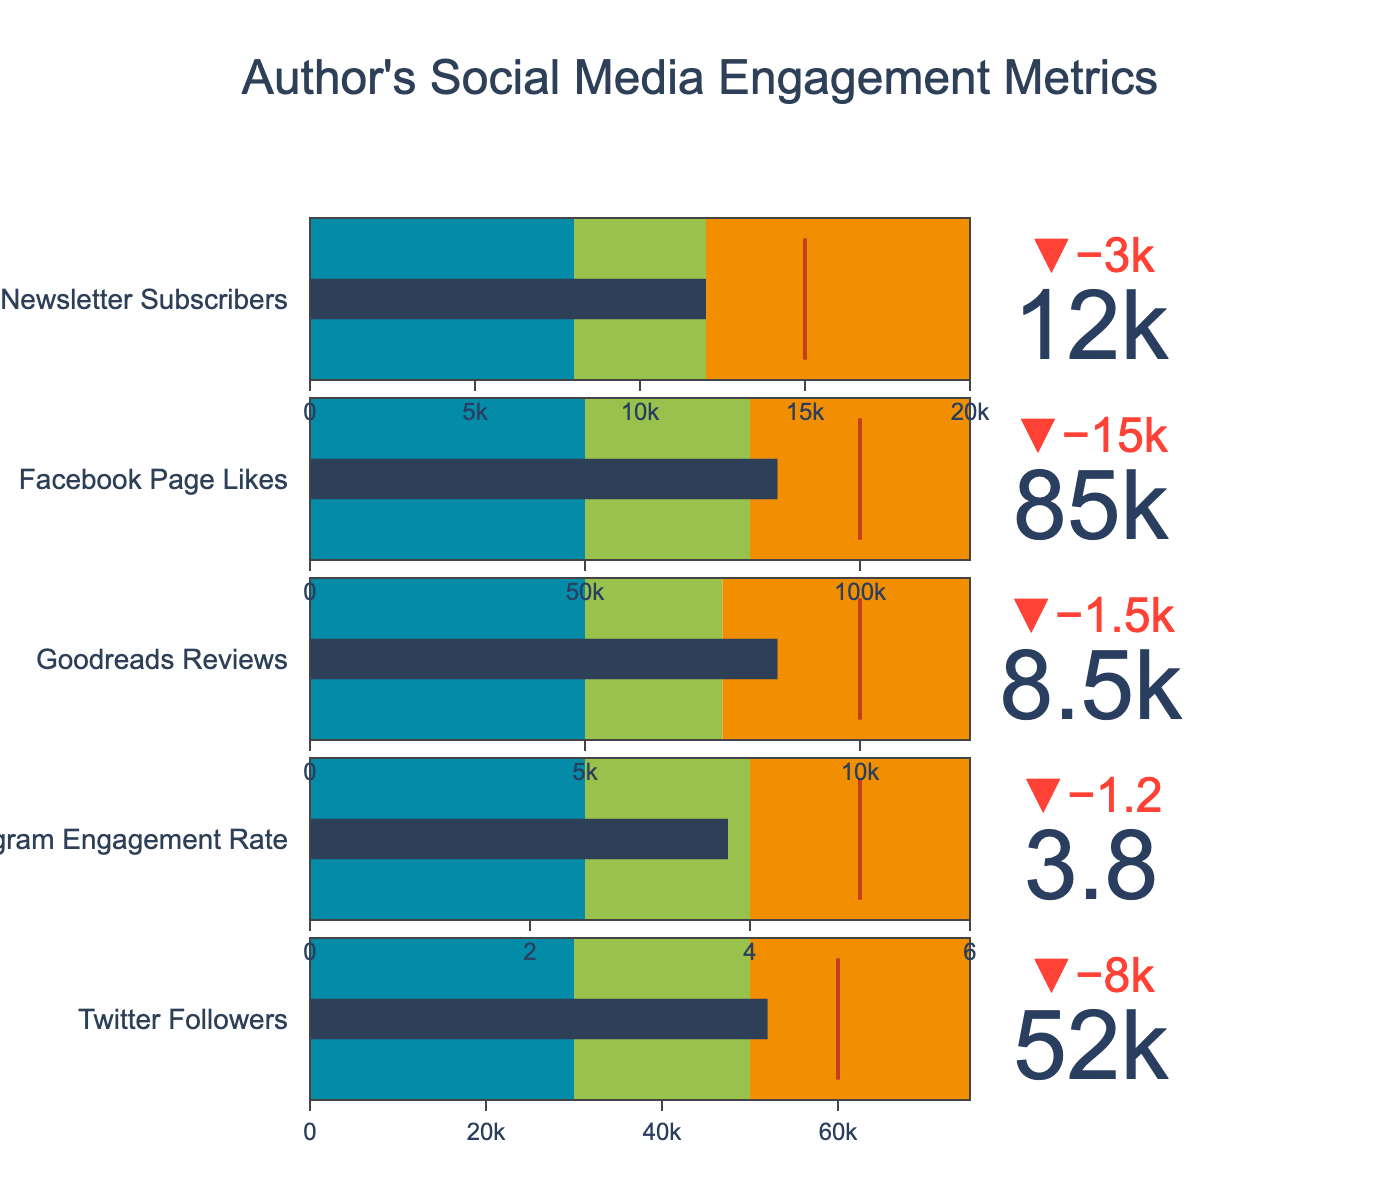What is the value of the actual Goodreads Reviews? The value of the actual Goodreads Reviews can be observed directly from the corresponding Bullet Chart, where it is 8500.
Answer: 8500 How does the actual number of Twitter Followers compare to the target number? The actual number of Twitter Followers is 52000, while the target number is 60000. Comparing them shows that the actual number is less than the target.
Answer: Less than What is the range of values considered 'Good' for the Instagram Engagement Rate? The range for 'Good' can be observed from the Bullet Chart. For Instagram Engagement Rate, it's between 4 and 6.
Answer: Between 4 and 6 Which metric is closest to its target value? By examining the delta indicators on each Bullet Chart, the metric with the smallest difference from its target is the Newsletter Subscribers, with an actual value of 12000 and a target of 15000.
Answer: Newsletter Subscribers What is the average value range for Facebook Page Likes? The Bullet Chart for Facebook Page Likes shows that the 'Good' range starts at 80000, and the 'Excellent' range ends at 120000. The average value range can be calculated by identifying the intervals: (50000 to 80000 is average).
Answer: 50000 to 80000 How many metrics have actual values within their 'Good' range? By observing the bars and colored ranges on each Bullet Chart, we see that the Instagram Engagement Rate (3.8) and Goodreads Reviews (8500) meet this criterion, so two metrics fall within 'Good'.
Answer: Two Which metric performs the best relative to its target? Each Bullet Chart includes a delta that indicates the difference from the target. The metric with the smallest delta compared to its target is the Newsletter Subscribers.
Answer: Newsletter Subscribers What is the difference between the actual and target values for Newsletter Subscribers? The target value for Newsletter Subscribers is 15000, and the actual value is 12000. The difference is 15000 - 12000 = 3000.
Answer: 3000 What is the range of values considered 'Excellent' for Twitter Followers? The Bullet Chart for Twitter Followers indicates the 'Excellent' range starts at 75000 and spans to the end of the chart.
Answer: Greater than 75000 What can you infer about the Author's social media engagement from these metrics? By examining where each actual value stands relative to its target and performance bands, we see that most metrics fall short of their targets, suggesting room for improvement in engaging with the audience.
Answer: Room for improvement 